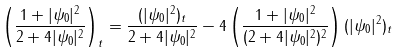<formula> <loc_0><loc_0><loc_500><loc_500>& \left ( \frac { 1 + | \psi _ { 0 } | ^ { 2 } } { 2 + 4 | \psi _ { 0 } | ^ { 2 } } \right ) _ { t } = \frac { ( | \psi _ { 0 } | ^ { 2 } ) _ { t } } { 2 + 4 | \psi _ { 0 } | ^ { 2 } } - 4 \left ( \frac { 1 + | \psi _ { 0 } | ^ { 2 } } { ( 2 + 4 | \psi _ { 0 } | ^ { 2 } ) ^ { 2 } } \right ) ( | \psi _ { 0 } | ^ { 2 } ) _ { t }</formula> 